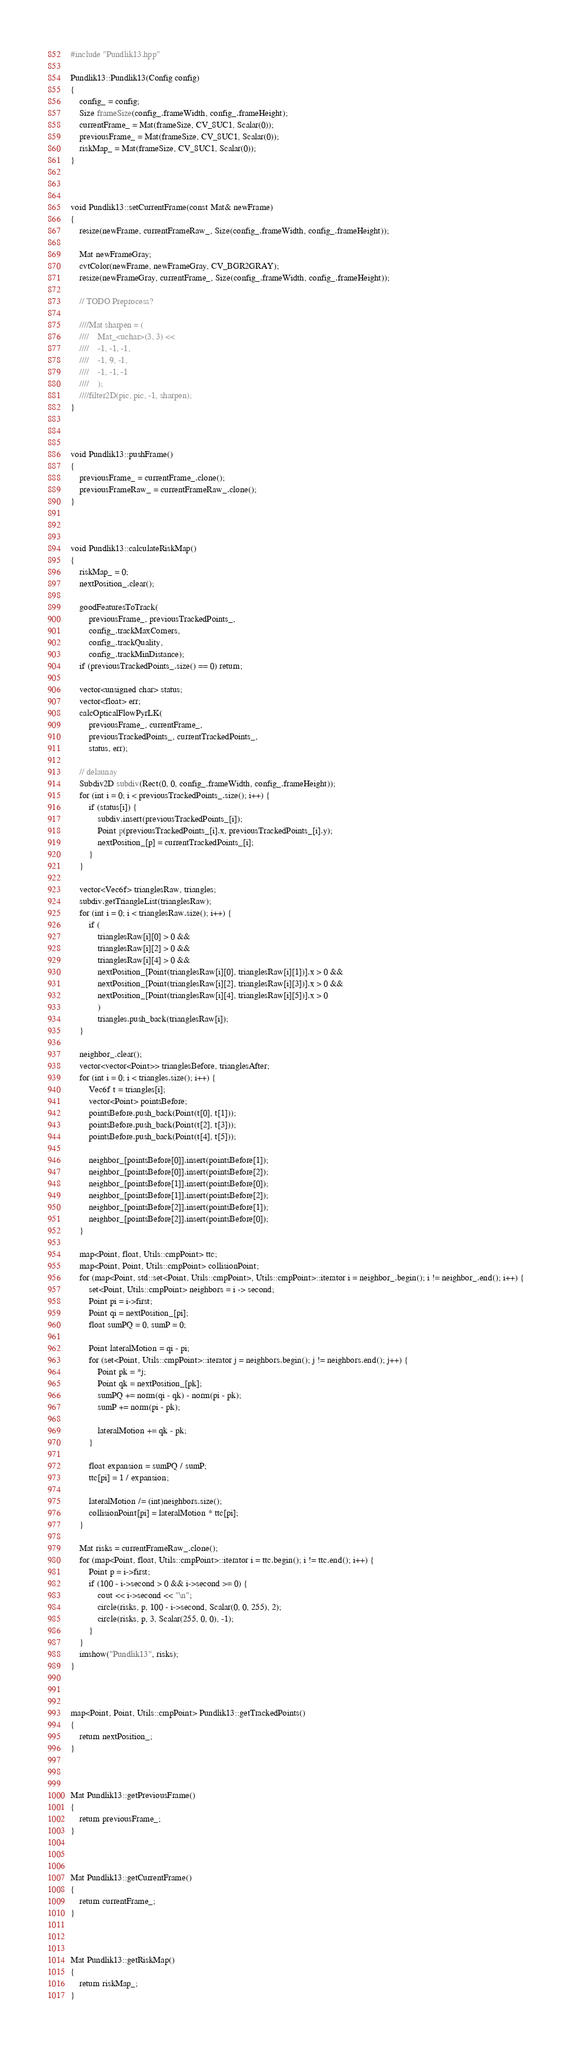Convert code to text. <code><loc_0><loc_0><loc_500><loc_500><_C++_>#include "Pundlik13.hpp"

Pundlik13::Pundlik13(Config config)
{
	config_ = config;
	Size frameSize(config_.frameWidth, config_.frameHeight);
	currentFrame_ = Mat(frameSize, CV_8UC1, Scalar(0));
	previousFrame_ = Mat(frameSize, CV_8UC1, Scalar(0));
	riskMap_ = Mat(frameSize, CV_8UC1, Scalar(0));
}



void Pundlik13::setCurrentFrame(const Mat& newFrame)
{
	resize(newFrame, currentFrameRaw_, Size(config_.frameWidth, config_.frameHeight));

	Mat newFrameGray;
	cvtColor(newFrame, newFrameGray, CV_BGR2GRAY);
	resize(newFrameGray, currentFrame_, Size(config_.frameWidth, config_.frameHeight));

	// TODO Preprocess?

	////Mat sharpen = (
	////	Mat_<uchar>(3, 3) <<
	////	-1, -1, -1,
	////	-1, 9, -1,
	////	-1, -1, -1
	////	);
	////filter2D(pic, pic, -1, sharpen);
}



void Pundlik13::pushFrame()
{
	previousFrame_ = currentFrame_.clone();
	previousFrameRaw_ = currentFrameRaw_.clone();
}



void Pundlik13::calculateRiskMap()
{
	riskMap_ = 0;
	nextPosition_.clear();

	goodFeaturesToTrack(
		previousFrame_, previousTrackedPoints_,
		config_.trackMaxCorners,
		config_.trackQuality,
		config_.trackMinDistance);
	if (previousTrackedPoints_.size() == 0) return;

	vector<unsigned char> status;
	vector<float> err;
	calcOpticalFlowPyrLK(
		previousFrame_, currentFrame_,
		previousTrackedPoints_, currentTrackedPoints_,
		status, err);

	// delaunay
	Subdiv2D subdiv(Rect(0, 0, config_.frameWidth, config_.frameHeight));
	for (int i = 0; i < previousTrackedPoints_.size(); i++) {
		if (status[i]) {
			subdiv.insert(previousTrackedPoints_[i]);
			Point p(previousTrackedPoints_[i].x, previousTrackedPoints_[i].y);
			nextPosition_[p] = currentTrackedPoints_[i];
		}
	}

	vector<Vec6f> trianglesRaw, triangles;
	subdiv.getTriangleList(trianglesRaw);
	for (int i = 0; i < trianglesRaw.size(); i++) {
		if (
			trianglesRaw[i][0] > 0 &&
			trianglesRaw[i][2] > 0 &&
			trianglesRaw[i][4] > 0 &&
			nextPosition_[Point(trianglesRaw[i][0], trianglesRaw[i][1])].x > 0 &&
			nextPosition_[Point(trianglesRaw[i][2], trianglesRaw[i][3])].x > 0 &&
			nextPosition_[Point(trianglesRaw[i][4], trianglesRaw[i][5])].x > 0
			)
			triangles.push_back(trianglesRaw[i]);
	}

	neighbor_.clear();
	vector<vector<Point>> trianglesBefore, trianglesAfter;
	for (int i = 0; i < triangles.size(); i++) {
		Vec6f t = triangles[i];
		vector<Point> pointsBefore;
		pointsBefore.push_back(Point(t[0], t[1]));
		pointsBefore.push_back(Point(t[2], t[3]));
		pointsBefore.push_back(Point(t[4], t[5]));

		neighbor_[pointsBefore[0]].insert(pointsBefore[1]);
		neighbor_[pointsBefore[0]].insert(pointsBefore[2]);
		neighbor_[pointsBefore[1]].insert(pointsBefore[0]);
		neighbor_[pointsBefore[1]].insert(pointsBefore[2]);
		neighbor_[pointsBefore[2]].insert(pointsBefore[1]);
		neighbor_[pointsBefore[2]].insert(pointsBefore[0]);
	}

	map<Point, float, Utils::cmpPoint> ttc;
	map<Point, Point, Utils::cmpPoint> collisionPoint;
	for (map<Point, std::set<Point, Utils::cmpPoint>, Utils::cmpPoint>::iterator i = neighbor_.begin(); i != neighbor_.end(); i++) {
		set<Point, Utils::cmpPoint> neighbors = i -> second;
		Point pi = i->first;
		Point qi = nextPosition_[pi];
		float sumPQ = 0, sumP = 0;

		Point lateralMotion = qi - pi;
		for (set<Point, Utils::cmpPoint>::iterator j = neighbors.begin(); j != neighbors.end(); j++) {
			Point pk = *j;
			Point qk = nextPosition_[pk];
			sumPQ += norm(qi - qk) - norm(pi - pk);
			sumP += norm(pi - pk);

			lateralMotion += qk - pk;
		}

		float expansion = sumPQ / sumP;
		ttc[pi] = 1 / expansion;

		lateralMotion /= (int)neighbors.size();
		collisionPoint[pi] = lateralMotion * ttc[pi];
	}

	Mat risks = currentFrameRaw_.clone();
	for (map<Point, float, Utils::cmpPoint>::iterator i = ttc.begin(); i != ttc.end(); i++) {
		Point p = i->first;
		if (100 - i->second > 0 && i->second >= 0) {
			cout << i->second << "\n";
			circle(risks, p, 100 - i->second, Scalar(0, 0, 255), 2);
			circle(risks, p, 3, Scalar(255, 0, 0), -1);
		}
	}
	imshow("Pundlik13", risks);
}



map<Point, Point, Utils::cmpPoint> Pundlik13::getTrackedPoints()
{
	return nextPosition_;
}



Mat Pundlik13::getPreviousFrame()
{
	return previousFrame_;
}



Mat Pundlik13::getCurrentFrame()
{
	return currentFrame_;
}



Mat Pundlik13::getRiskMap()
{
	return riskMap_;
}</code> 